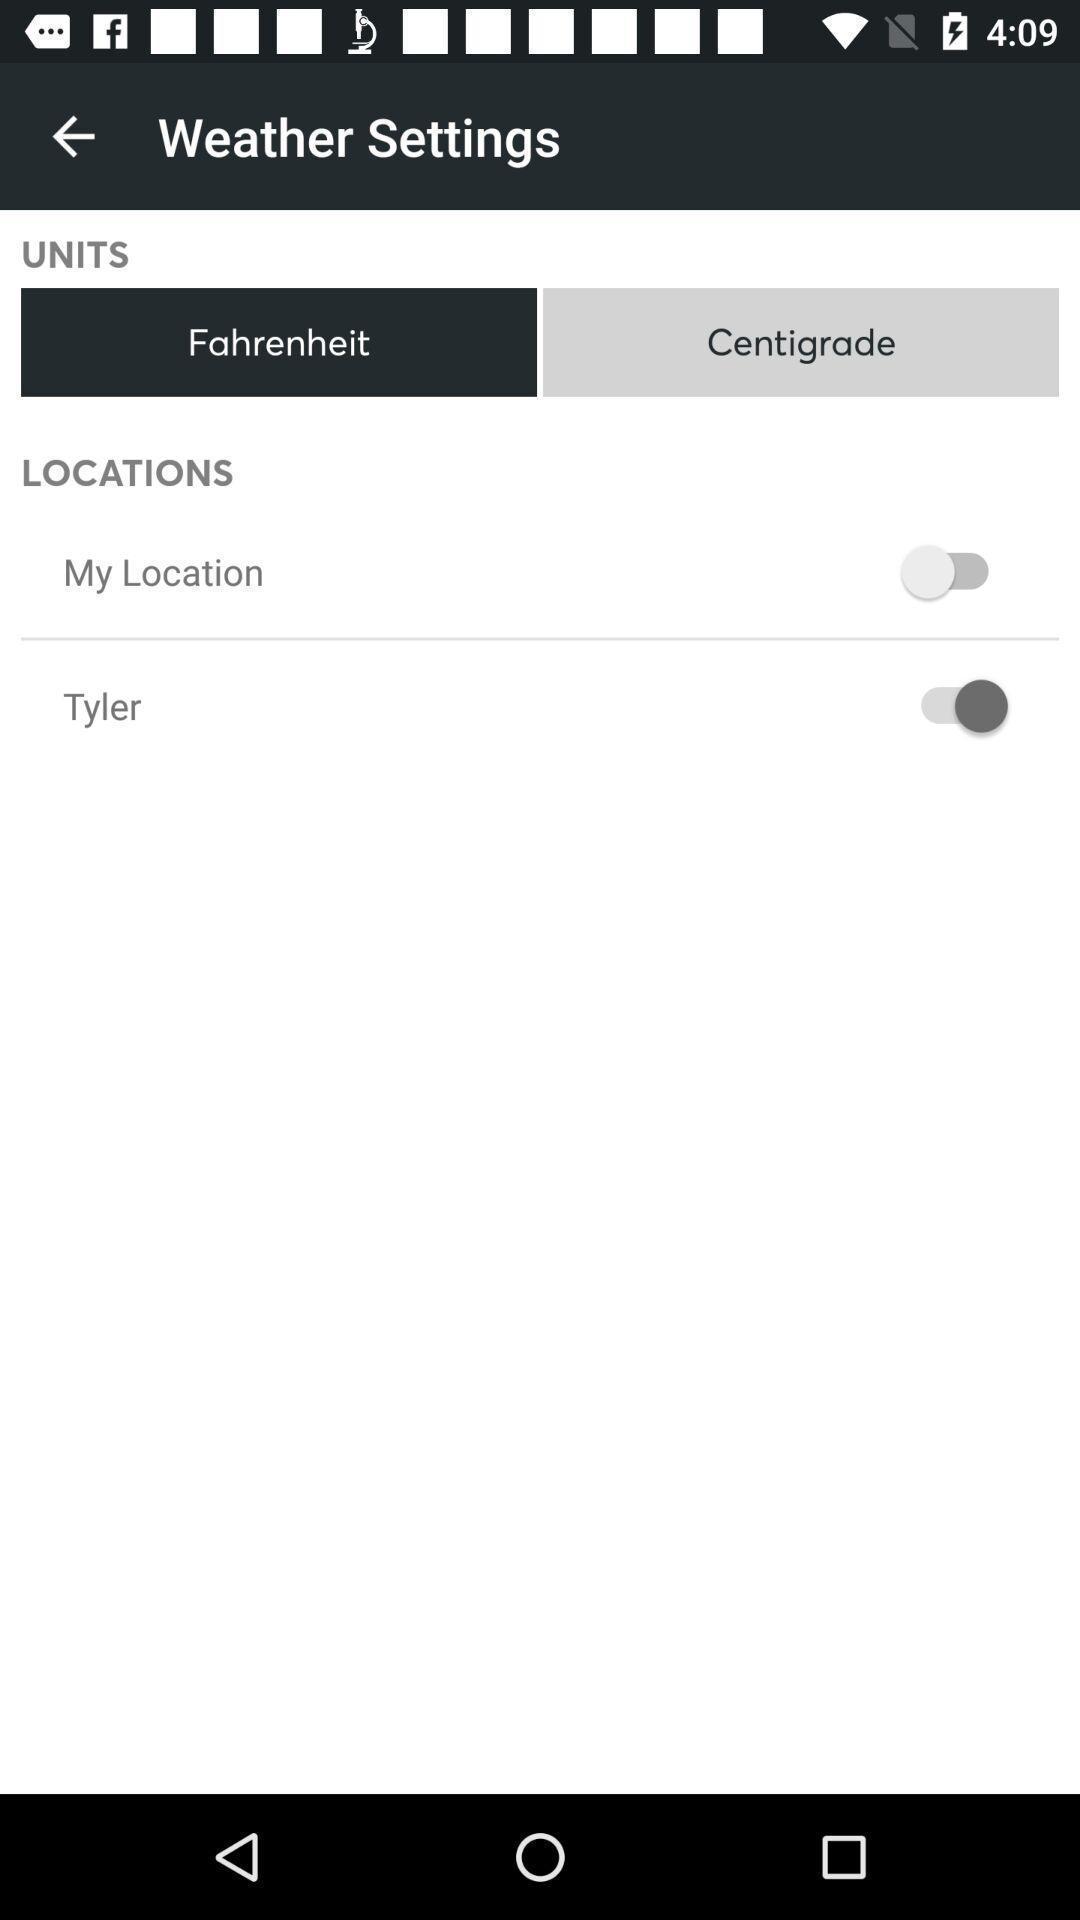Explain what's happening in this screen capture. Various options under weather settings. 